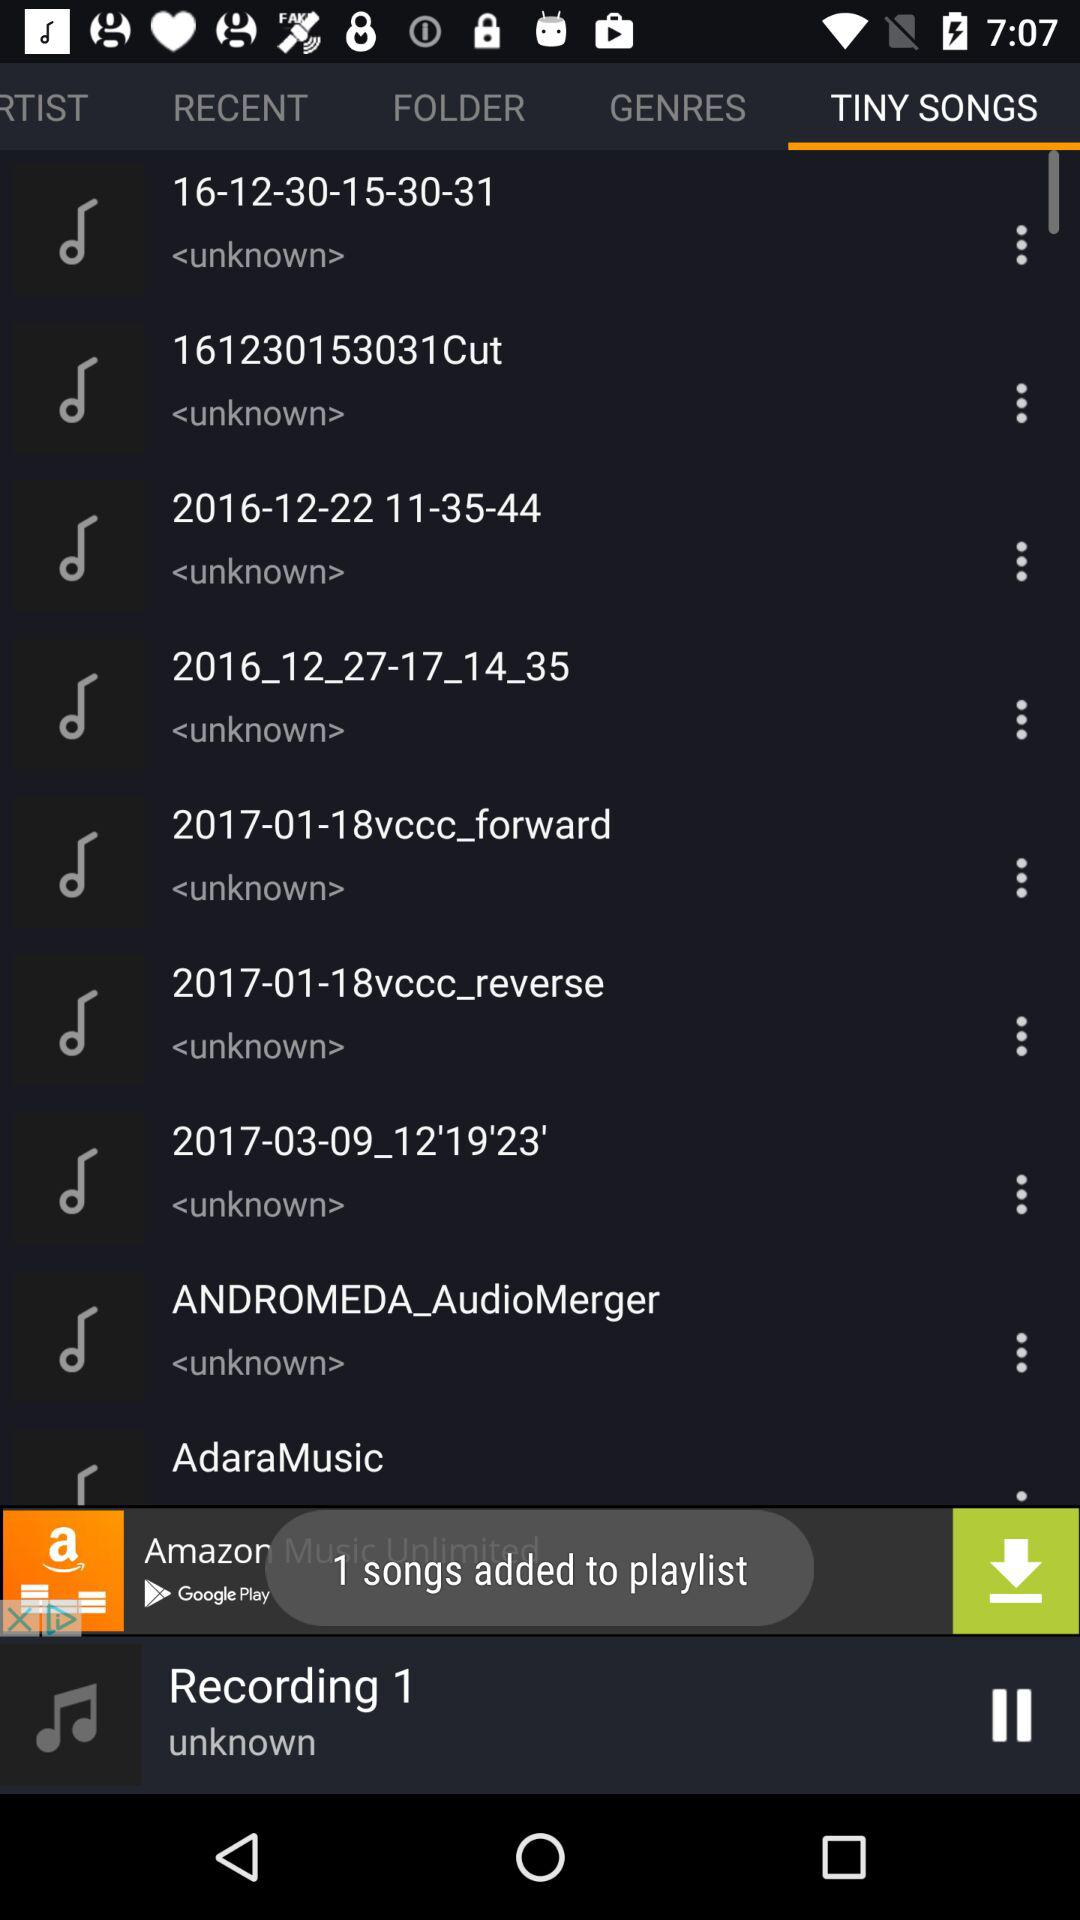How many songs are added to the playlist? There is 1 song added to the playlist. 